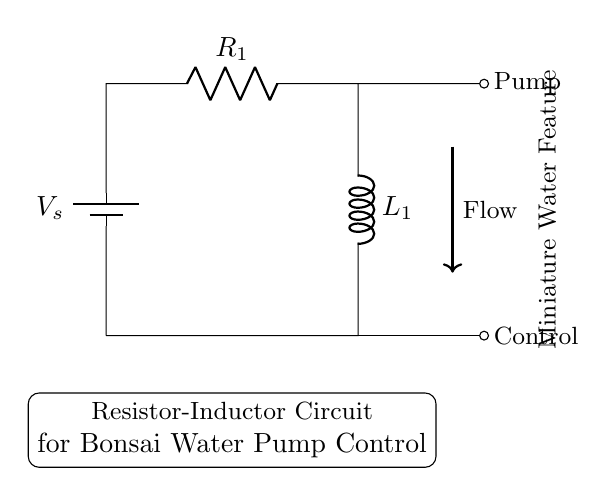What components are in this circuit? The circuit consists of a battery, a resistor, and an inductor, as indicated by their symbols.
Answer: battery, resistor, inductor What is the purpose of the inductor in this circuit? The inductor is used to smooth out the current flow to the pump, creating a more stable output when the power is applied or removed.
Answer: smooth current What is connected to the inductor's output? The output of the inductor is connected to a pump, which operates the water feature.
Answer: Pump What is the flow direction indicated in the circuit? The thick arrow labeled "Flow" points downward, indicating the direction of water flow from the system.
Answer: downward What happens to the current when the circuit is powered on? When powered on, the current initially rises slowly due to the inductor's property of resisting changes in current, eventually reaching a steady state.
Answer: rises slowly How does the resistor affect the circuit operation? The resistor limits the current that can pass through the circuit, controlling the overall energy supplied to the inductor and pump.
Answer: limits current What type of circuit is this specifically classified as? This circuit is classified as a Resistor-Inductor circuit, which is characterized by the presence of both a resistor and an inductor in series.
Answer: Resistor-Inductor circuit 